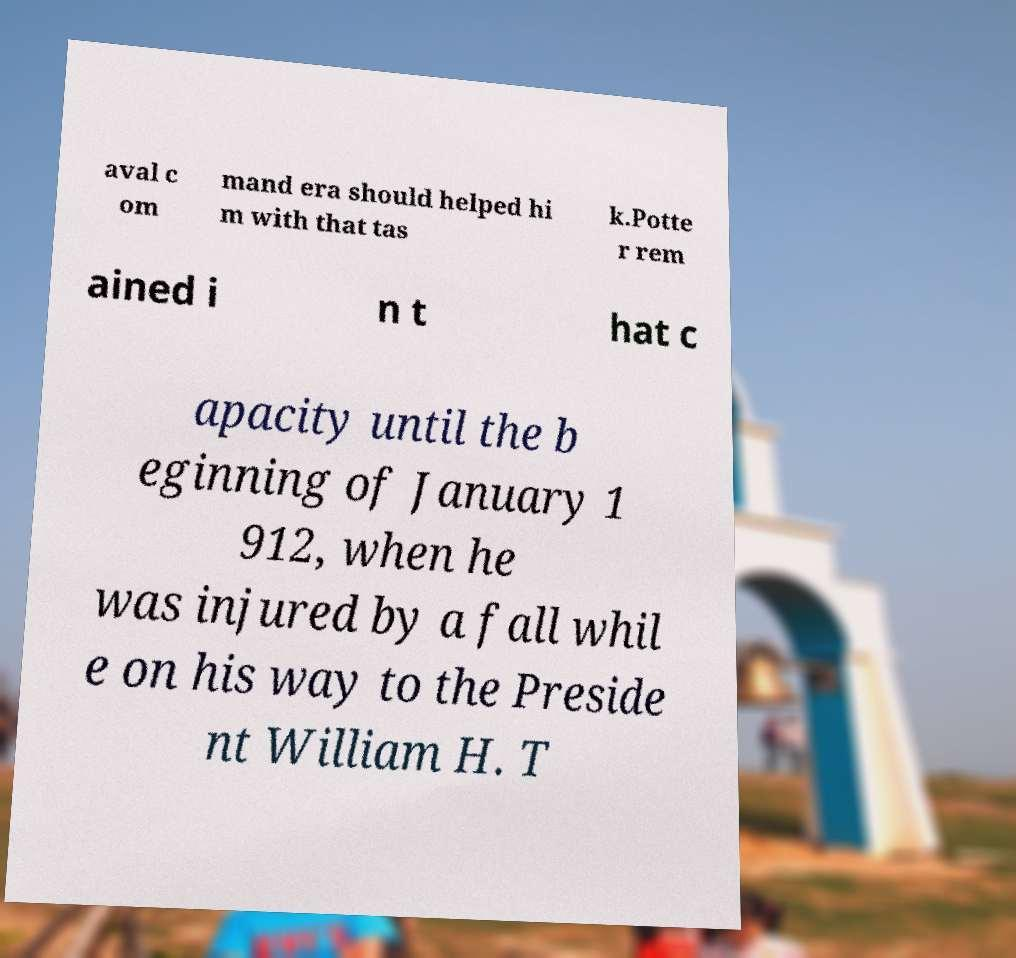Can you read and provide the text displayed in the image?This photo seems to have some interesting text. Can you extract and type it out for me? aval c om mand era should helped hi m with that tas k.Potte r rem ained i n t hat c apacity until the b eginning of January 1 912, when he was injured by a fall whil e on his way to the Preside nt William H. T 